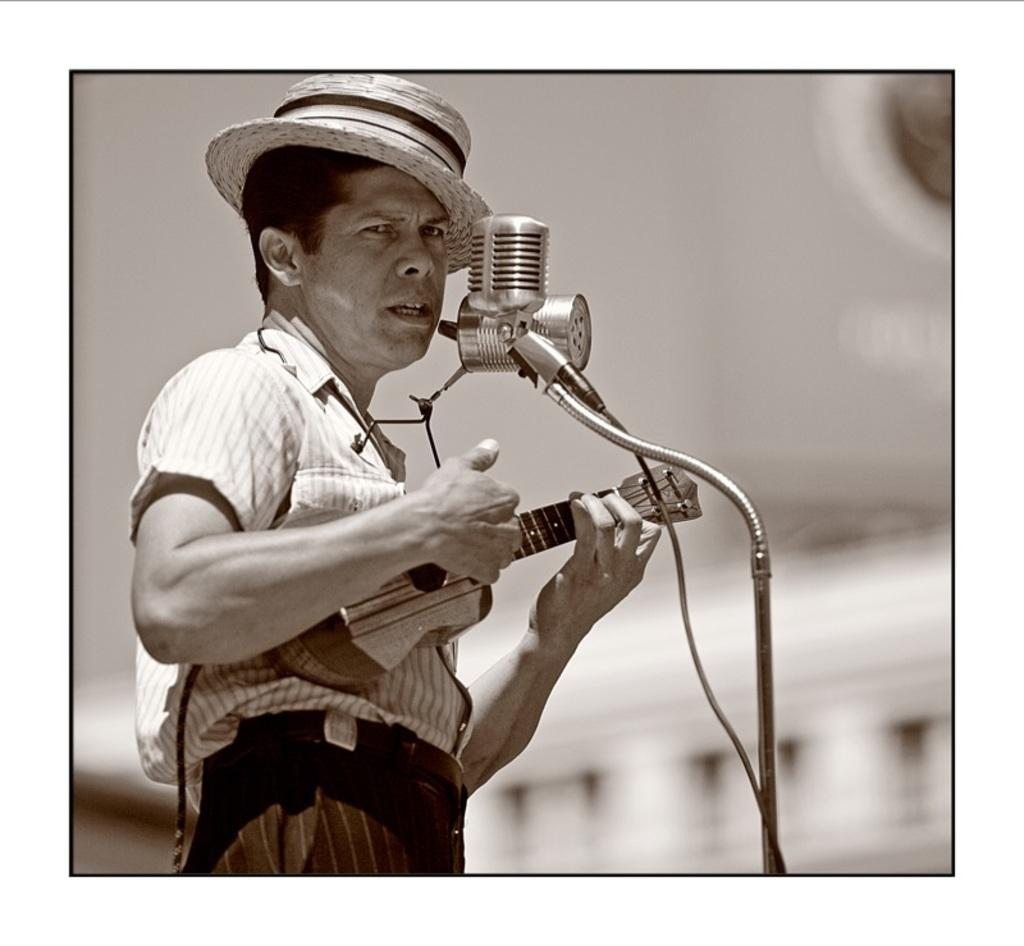What is the main subject of the image? There is a person in the image. What is the person doing in the image? The person is playing a guitar. What object is the person standing in front of? The person is standing in front of a microphone. Can you describe the background of the image? The background of the image is blurred. How many goldfish are swimming in the air behind the person in the image? There are no goldfish present in the image, and the air is not visible in the image. 